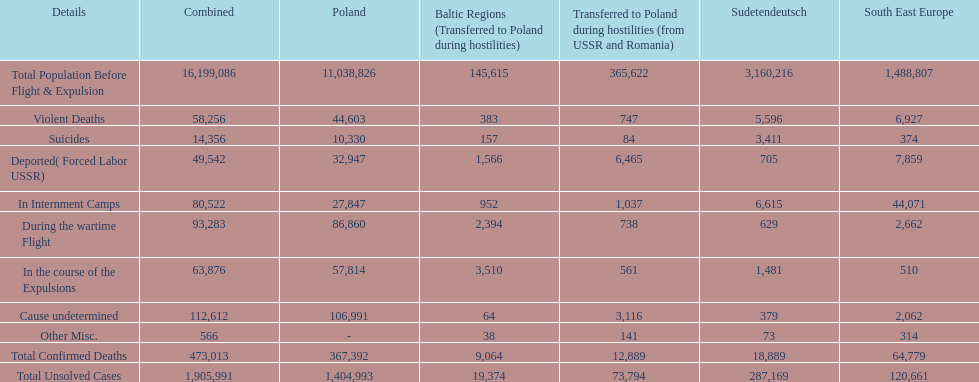What is the total number of violent deaths across all regions? 58,256. 